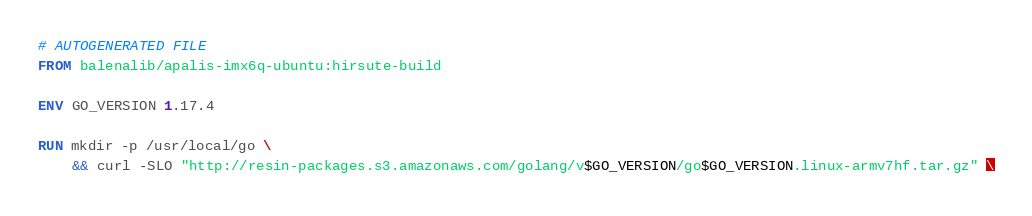<code> <loc_0><loc_0><loc_500><loc_500><_Dockerfile_># AUTOGENERATED FILE
FROM balenalib/apalis-imx6q-ubuntu:hirsute-build

ENV GO_VERSION 1.17.4

RUN mkdir -p /usr/local/go \
	&& curl -SLO "http://resin-packages.s3.amazonaws.com/golang/v$GO_VERSION/go$GO_VERSION.linux-armv7hf.tar.gz" \</code> 